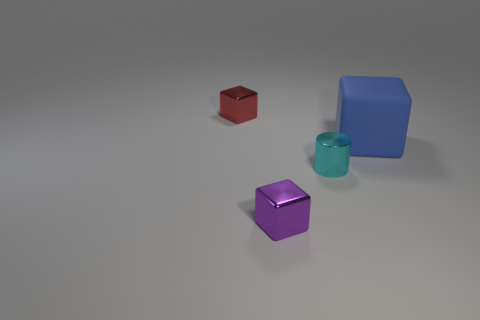Add 4 metallic balls. How many objects exist? 8 Subtract all red blocks. How many blocks are left? 2 Subtract all tiny purple cubes. How many cubes are left? 2 Subtract 0 gray balls. How many objects are left? 4 Subtract all cylinders. How many objects are left? 3 Subtract 1 blocks. How many blocks are left? 2 Subtract all purple cylinders. Subtract all brown balls. How many cylinders are left? 1 Subtract all green blocks. How many blue cylinders are left? 0 Subtract all purple metal objects. Subtract all metal blocks. How many objects are left? 1 Add 4 small purple metal cubes. How many small purple metal cubes are left? 5 